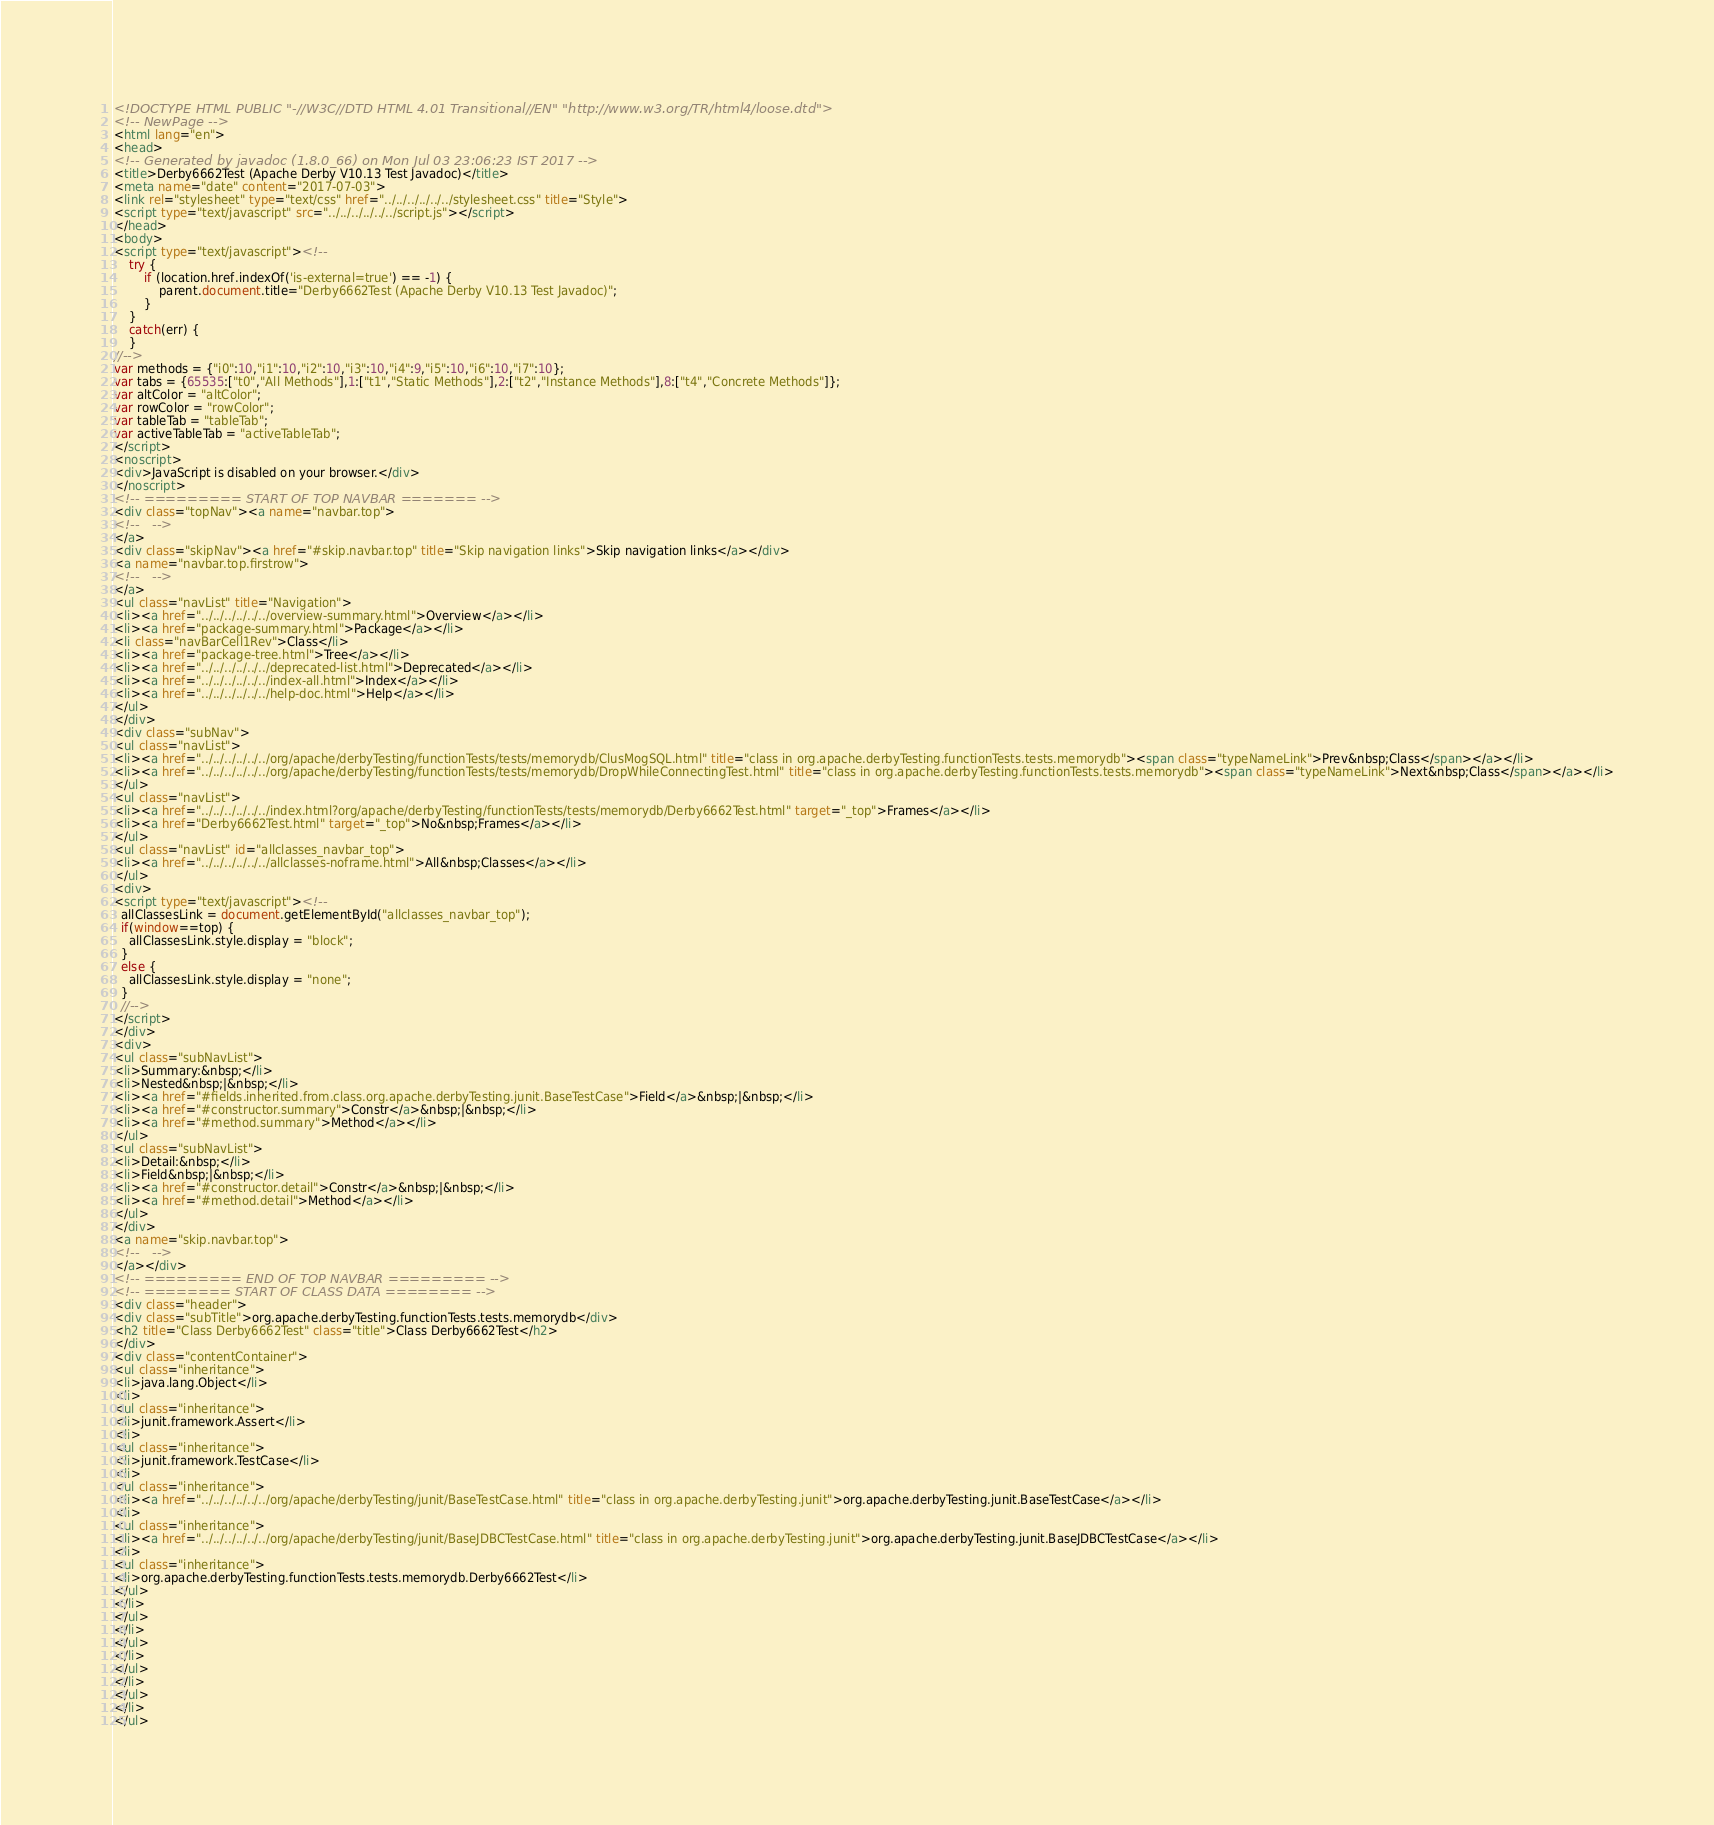<code> <loc_0><loc_0><loc_500><loc_500><_HTML_><!DOCTYPE HTML PUBLIC "-//W3C//DTD HTML 4.01 Transitional//EN" "http://www.w3.org/TR/html4/loose.dtd">
<!-- NewPage -->
<html lang="en">
<head>
<!-- Generated by javadoc (1.8.0_66) on Mon Jul 03 23:06:23 IST 2017 -->
<title>Derby6662Test (Apache Derby V10.13 Test Javadoc)</title>
<meta name="date" content="2017-07-03">
<link rel="stylesheet" type="text/css" href="../../../../../../stylesheet.css" title="Style">
<script type="text/javascript" src="../../../../../../script.js"></script>
</head>
<body>
<script type="text/javascript"><!--
    try {
        if (location.href.indexOf('is-external=true') == -1) {
            parent.document.title="Derby6662Test (Apache Derby V10.13 Test Javadoc)";
        }
    }
    catch(err) {
    }
//-->
var methods = {"i0":10,"i1":10,"i2":10,"i3":10,"i4":9,"i5":10,"i6":10,"i7":10};
var tabs = {65535:["t0","All Methods"],1:["t1","Static Methods"],2:["t2","Instance Methods"],8:["t4","Concrete Methods"]};
var altColor = "altColor";
var rowColor = "rowColor";
var tableTab = "tableTab";
var activeTableTab = "activeTableTab";
</script>
<noscript>
<div>JavaScript is disabled on your browser.</div>
</noscript>
<!-- ========= START OF TOP NAVBAR ======= -->
<div class="topNav"><a name="navbar.top">
<!--   -->
</a>
<div class="skipNav"><a href="#skip.navbar.top" title="Skip navigation links">Skip navigation links</a></div>
<a name="navbar.top.firstrow">
<!--   -->
</a>
<ul class="navList" title="Navigation">
<li><a href="../../../../../../overview-summary.html">Overview</a></li>
<li><a href="package-summary.html">Package</a></li>
<li class="navBarCell1Rev">Class</li>
<li><a href="package-tree.html">Tree</a></li>
<li><a href="../../../../../../deprecated-list.html">Deprecated</a></li>
<li><a href="../../../../../../index-all.html">Index</a></li>
<li><a href="../../../../../../help-doc.html">Help</a></li>
</ul>
</div>
<div class="subNav">
<ul class="navList">
<li><a href="../../../../../../org/apache/derbyTesting/functionTests/tests/memorydb/ClusMogSQL.html" title="class in org.apache.derbyTesting.functionTests.tests.memorydb"><span class="typeNameLink">Prev&nbsp;Class</span></a></li>
<li><a href="../../../../../../org/apache/derbyTesting/functionTests/tests/memorydb/DropWhileConnectingTest.html" title="class in org.apache.derbyTesting.functionTests.tests.memorydb"><span class="typeNameLink">Next&nbsp;Class</span></a></li>
</ul>
<ul class="navList">
<li><a href="../../../../../../index.html?org/apache/derbyTesting/functionTests/tests/memorydb/Derby6662Test.html" target="_top">Frames</a></li>
<li><a href="Derby6662Test.html" target="_top">No&nbsp;Frames</a></li>
</ul>
<ul class="navList" id="allclasses_navbar_top">
<li><a href="../../../../../../allclasses-noframe.html">All&nbsp;Classes</a></li>
</ul>
<div>
<script type="text/javascript"><!--
  allClassesLink = document.getElementById("allclasses_navbar_top");
  if(window==top) {
    allClassesLink.style.display = "block";
  }
  else {
    allClassesLink.style.display = "none";
  }
  //-->
</script>
</div>
<div>
<ul class="subNavList">
<li>Summary:&nbsp;</li>
<li>Nested&nbsp;|&nbsp;</li>
<li><a href="#fields.inherited.from.class.org.apache.derbyTesting.junit.BaseTestCase">Field</a>&nbsp;|&nbsp;</li>
<li><a href="#constructor.summary">Constr</a>&nbsp;|&nbsp;</li>
<li><a href="#method.summary">Method</a></li>
</ul>
<ul class="subNavList">
<li>Detail:&nbsp;</li>
<li>Field&nbsp;|&nbsp;</li>
<li><a href="#constructor.detail">Constr</a>&nbsp;|&nbsp;</li>
<li><a href="#method.detail">Method</a></li>
</ul>
</div>
<a name="skip.navbar.top">
<!--   -->
</a></div>
<!-- ========= END OF TOP NAVBAR ========= -->
<!-- ======== START OF CLASS DATA ======== -->
<div class="header">
<div class="subTitle">org.apache.derbyTesting.functionTests.tests.memorydb</div>
<h2 title="Class Derby6662Test" class="title">Class Derby6662Test</h2>
</div>
<div class="contentContainer">
<ul class="inheritance">
<li>java.lang.Object</li>
<li>
<ul class="inheritance">
<li>junit.framework.Assert</li>
<li>
<ul class="inheritance">
<li>junit.framework.TestCase</li>
<li>
<ul class="inheritance">
<li><a href="../../../../../../org/apache/derbyTesting/junit/BaseTestCase.html" title="class in org.apache.derbyTesting.junit">org.apache.derbyTesting.junit.BaseTestCase</a></li>
<li>
<ul class="inheritance">
<li><a href="../../../../../../org/apache/derbyTesting/junit/BaseJDBCTestCase.html" title="class in org.apache.derbyTesting.junit">org.apache.derbyTesting.junit.BaseJDBCTestCase</a></li>
<li>
<ul class="inheritance">
<li>org.apache.derbyTesting.functionTests.tests.memorydb.Derby6662Test</li>
</ul>
</li>
</ul>
</li>
</ul>
</li>
</ul>
</li>
</ul>
</li>
</ul></code> 